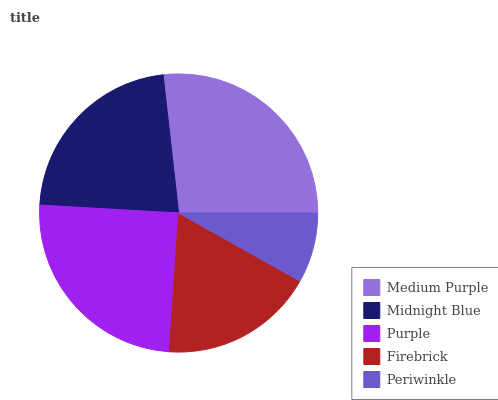Is Periwinkle the minimum?
Answer yes or no. Yes. Is Medium Purple the maximum?
Answer yes or no. Yes. Is Midnight Blue the minimum?
Answer yes or no. No. Is Midnight Blue the maximum?
Answer yes or no. No. Is Medium Purple greater than Midnight Blue?
Answer yes or no. Yes. Is Midnight Blue less than Medium Purple?
Answer yes or no. Yes. Is Midnight Blue greater than Medium Purple?
Answer yes or no. No. Is Medium Purple less than Midnight Blue?
Answer yes or no. No. Is Midnight Blue the high median?
Answer yes or no. Yes. Is Midnight Blue the low median?
Answer yes or no. Yes. Is Periwinkle the high median?
Answer yes or no. No. Is Periwinkle the low median?
Answer yes or no. No. 